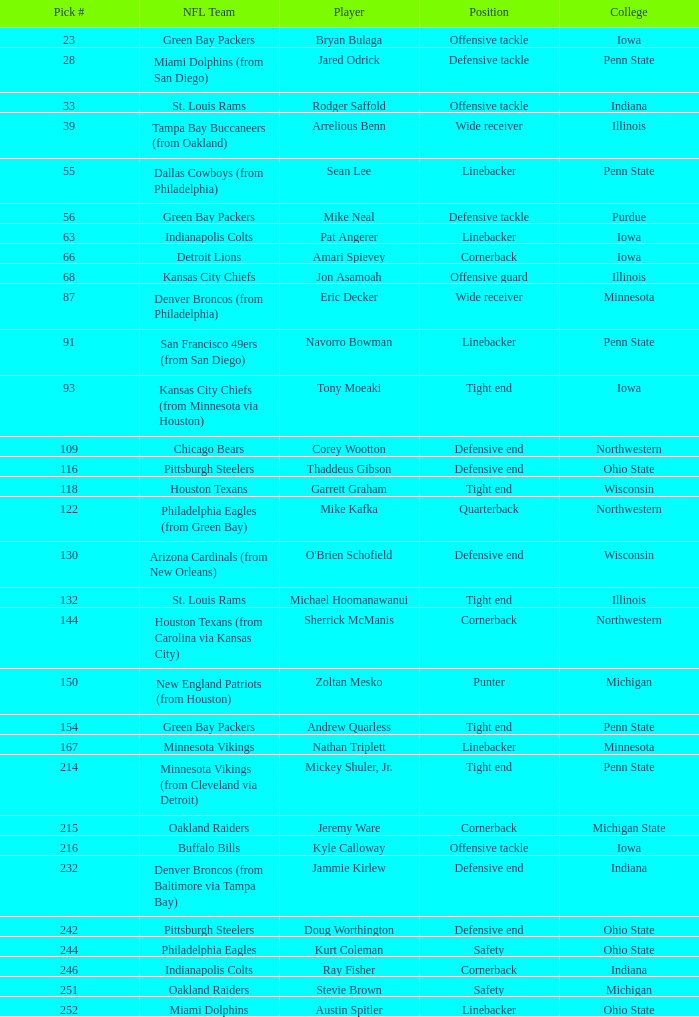How many nfl squads has stevie brown played for? 1.0. 